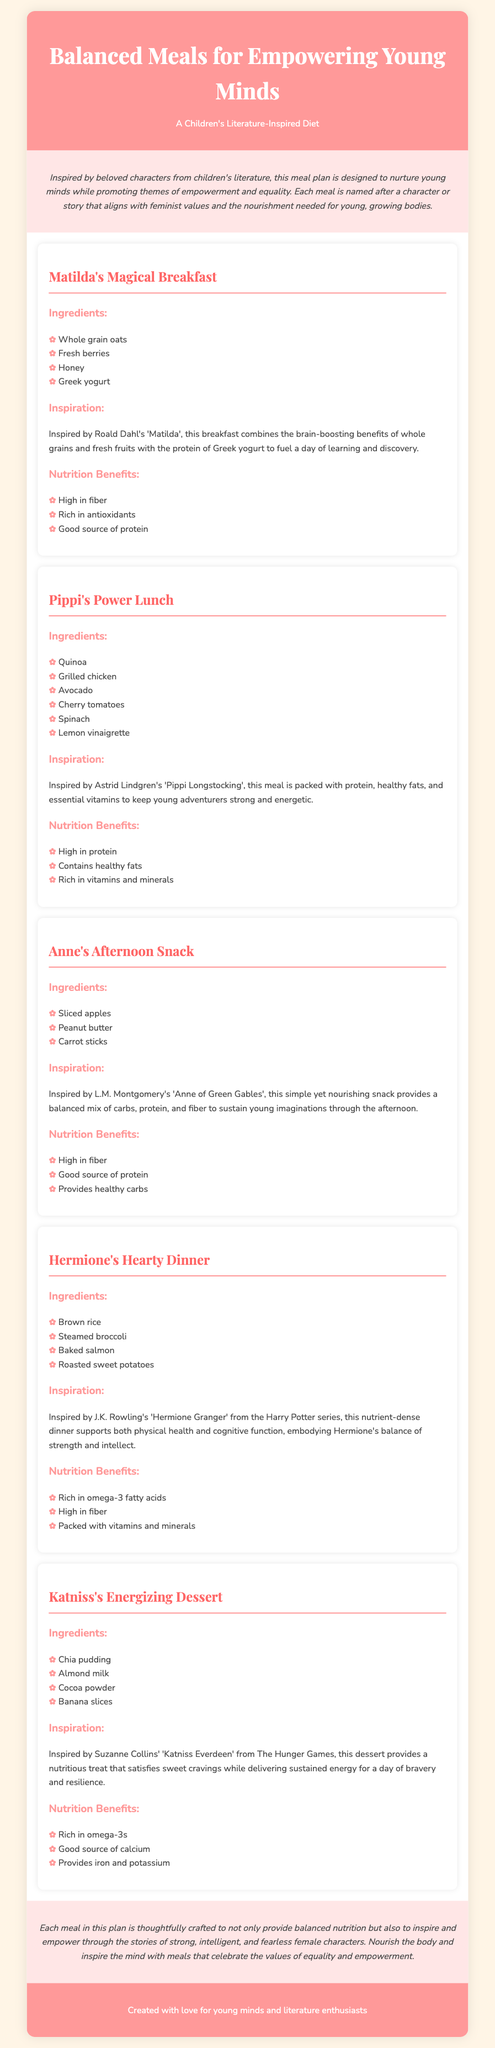What is the title of the meal plan? The title of the meal plan is mentioned in the header of the document.
Answer: Balanced Meals for Empowering Young Minds How many meals are listed in the meal plan? The meal plan includes five different meals, each dedicated to a character or story.
Answer: Five Who is the inspiration for the breakfast meal? The breakfast meal draws inspiration from a specific character in children's literature.
Answer: Matilda What are the main ingredients in Pippi's Power Lunch? The ingredients for Pippi's Power Lunch include various foods listed in the meal section.
Answer: Quinoa, grilled chicken, avocado, cherry tomatoes, spinach, lemon vinaigrette What type of salad is included in Hermione's Hearty Dinner? The meal section describes a specific side dish included with Hermione's dinner.
Answer: Steamed broccoli What is a featured dessert in the meal plan? The dessert that represents a character is stated in the section for Katniss's dessert.
Answer: Chia pudding What nutritional benefit is highlighted for Anne's Afternoon Snack? The document lists a few nutritional benefits specific to the snack prepared for Anne.
Answer: High in fiber Which character does the energizing dessert represent? The dessert in this meal plan is named after a character known for her bravery.
Answer: Katniss Everdeen What theme does the meal plan promote? The introduction of the meal plan discusses the overarching theme it aims to convey.
Answer: Empowerment and equality 